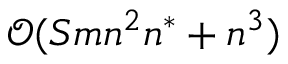<formula> <loc_0><loc_0><loc_500><loc_500>\mathcal { O } ( S m n ^ { 2 } n ^ { * } + n ^ { 3 } )</formula> 